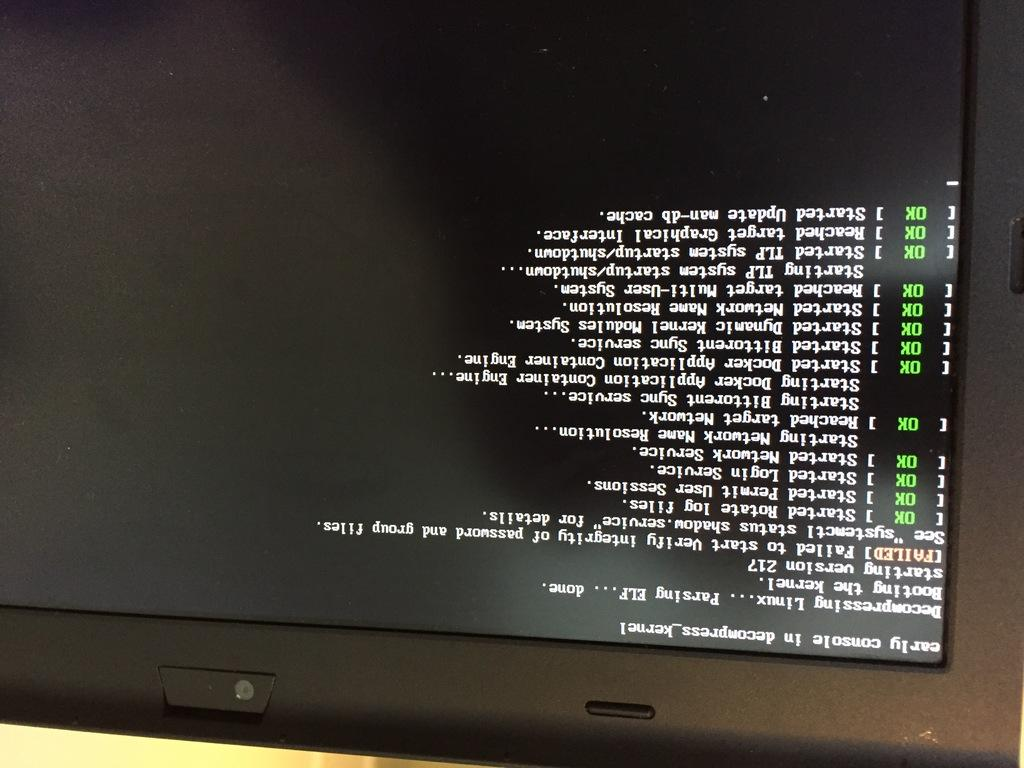<image>
Present a compact description of the photo's key features. Upside down text starting with Carly console is displayed on a monitor. 